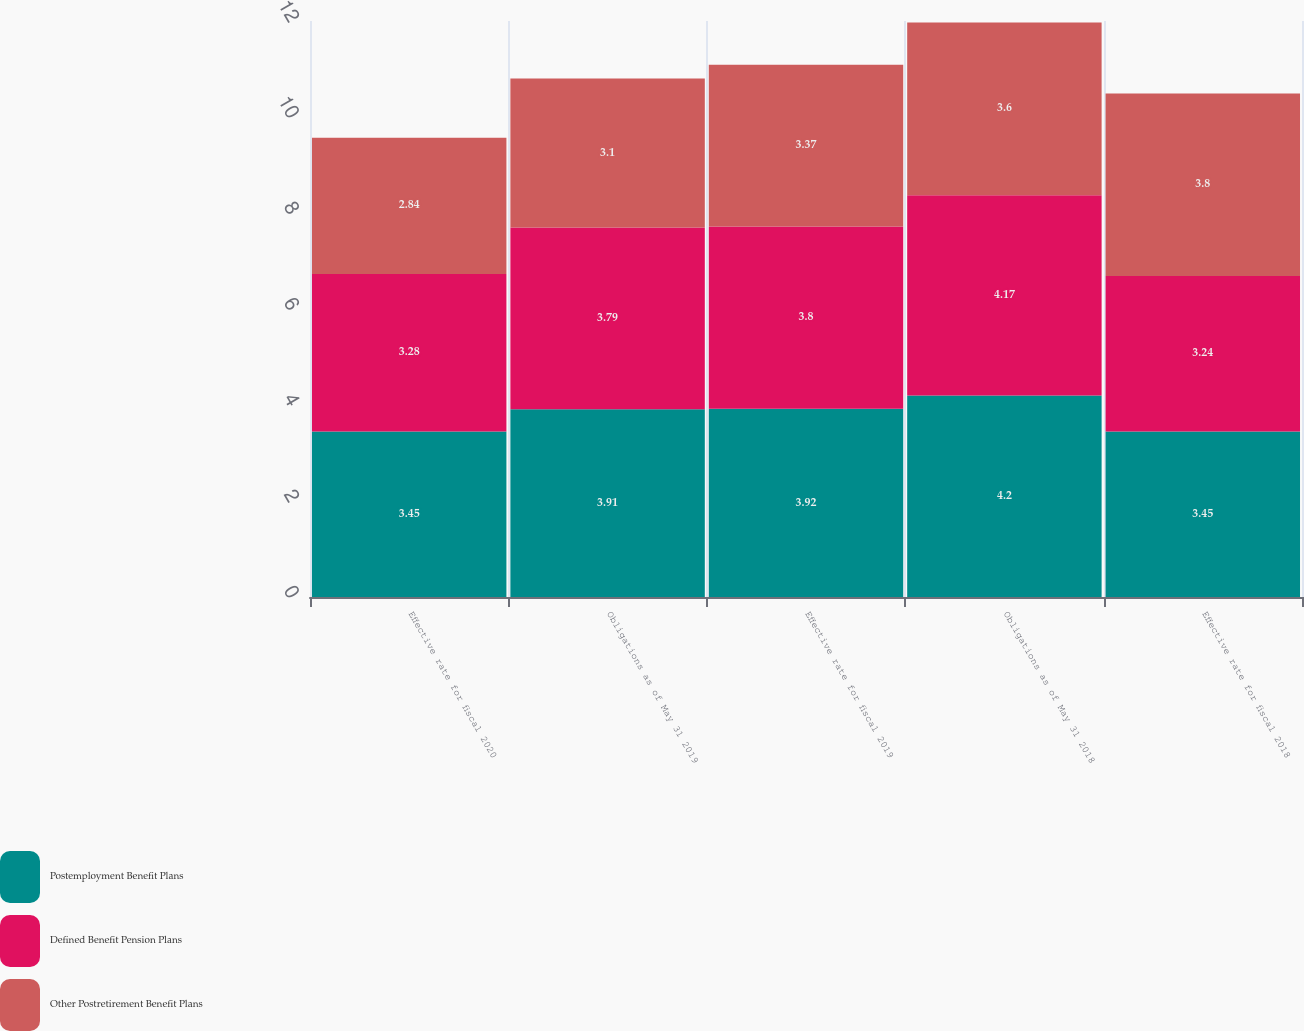<chart> <loc_0><loc_0><loc_500><loc_500><stacked_bar_chart><ecel><fcel>Effective rate for fiscal 2020<fcel>Obligations as of May 31 2019<fcel>Effective rate for fiscal 2019<fcel>Obligations as of May 31 2018<fcel>Effective rate for fiscal 2018<nl><fcel>Postemployment Benefit Plans<fcel>3.45<fcel>3.91<fcel>3.92<fcel>4.2<fcel>3.45<nl><fcel>Defined Benefit Pension Plans<fcel>3.28<fcel>3.79<fcel>3.8<fcel>4.17<fcel>3.24<nl><fcel>Other Postretirement Benefit Plans<fcel>2.84<fcel>3.1<fcel>3.37<fcel>3.6<fcel>3.8<nl></chart> 